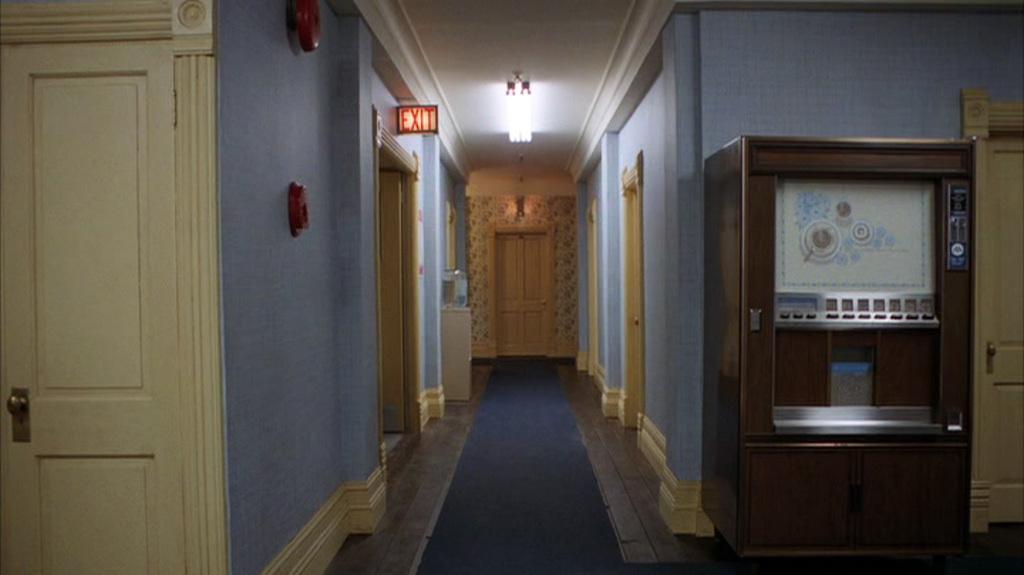In one or two sentences, can you explain what this image depicts? In the image there is verandah in the middle with carpet, on either side of it there are doors to the rooms and above there is a light over the ceiling and in the back there is another door on the wall. 